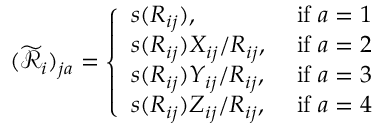<formula> <loc_0><loc_0><loc_500><loc_500>( \widetilde { \mathcal { R } } _ { i } ) _ { j a } = \left \{ \begin{array} { l l } { s ( R _ { i j } ) , } & { i f a = 1 } \\ { s ( R _ { i j } ) X _ { i j } / R _ { i j } , } & { i f a = 2 } \\ { s ( R _ { i j } ) Y _ { i j } / R _ { i j } , } & { i f a = 3 } \\ { s ( R _ { i j } ) Z _ { i j } / R _ { i j } , } & { i f a = 4 } \end{array}</formula> 